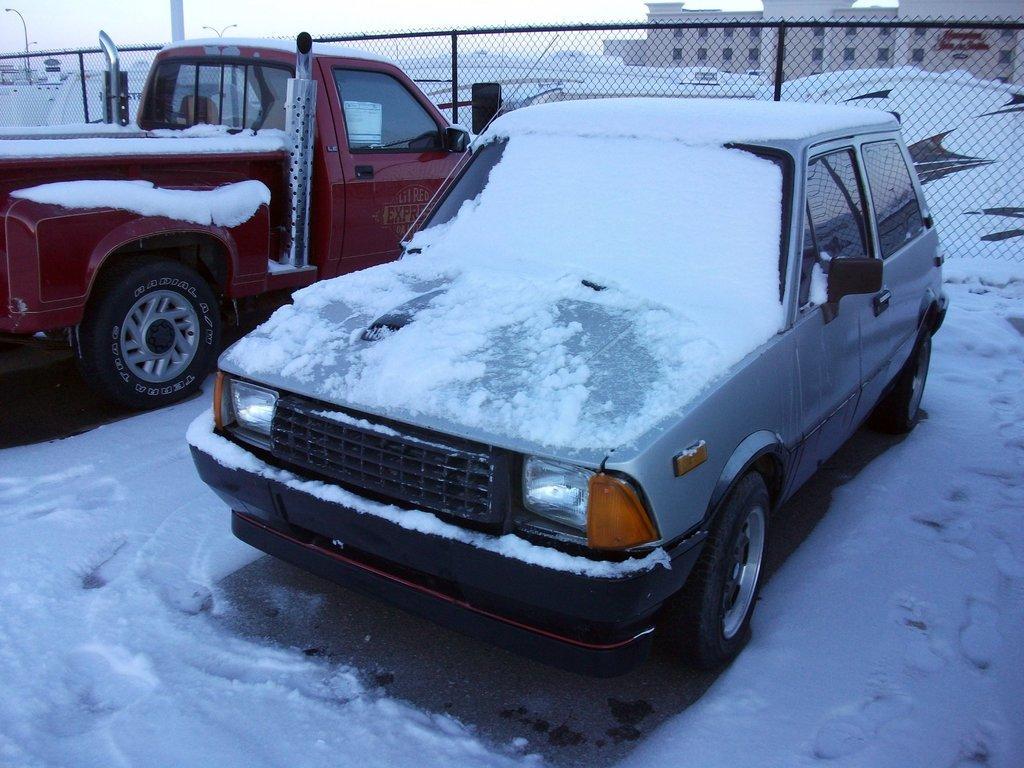Can you describe this image briefly? In this image in the foreground there are two vehicles visible, on which there is a snow, backside of vehicle there is a fence, at the top there is the sky and building, in the top left there is a pole. 